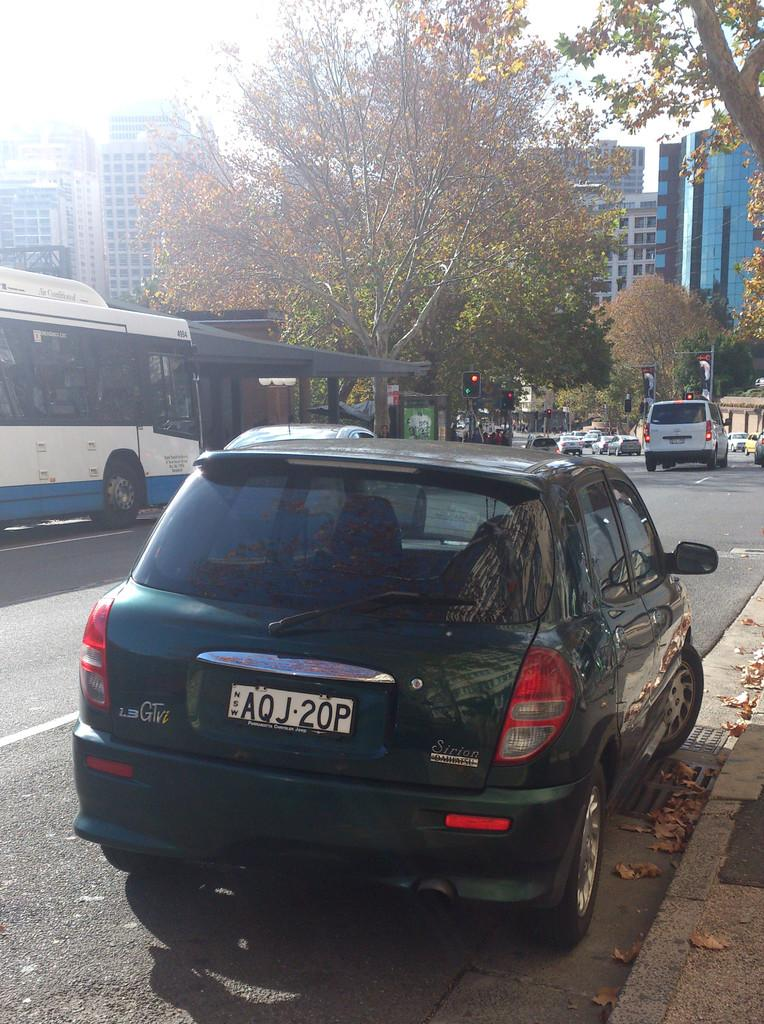What can be seen on the road in the image? There are vehicles on the road in the image. What is present in the background to help regulate traffic? There are traffic lights in the background of the image. What type of natural elements can be seen in the background? There are trees in the background of the image. What type of man-made structures are visible in the background? There are buildings in the background of the image. How many children are playing near the vehicles in the image? There are no children present in the image; it only shows vehicles on the road and elements in the background. 